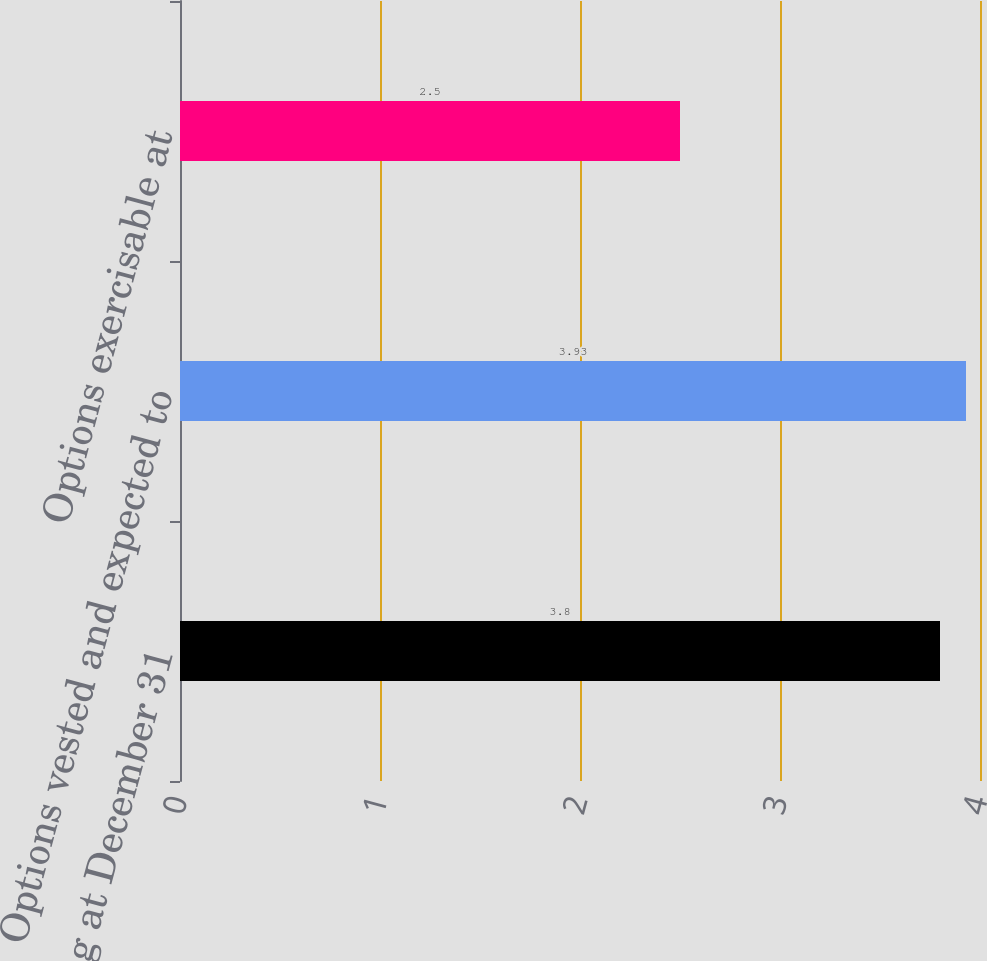Convert chart. <chart><loc_0><loc_0><loc_500><loc_500><bar_chart><fcel>Outstanding at December 31<fcel>Options vested and expected to<fcel>Options exercisable at<nl><fcel>3.8<fcel>3.93<fcel>2.5<nl></chart> 